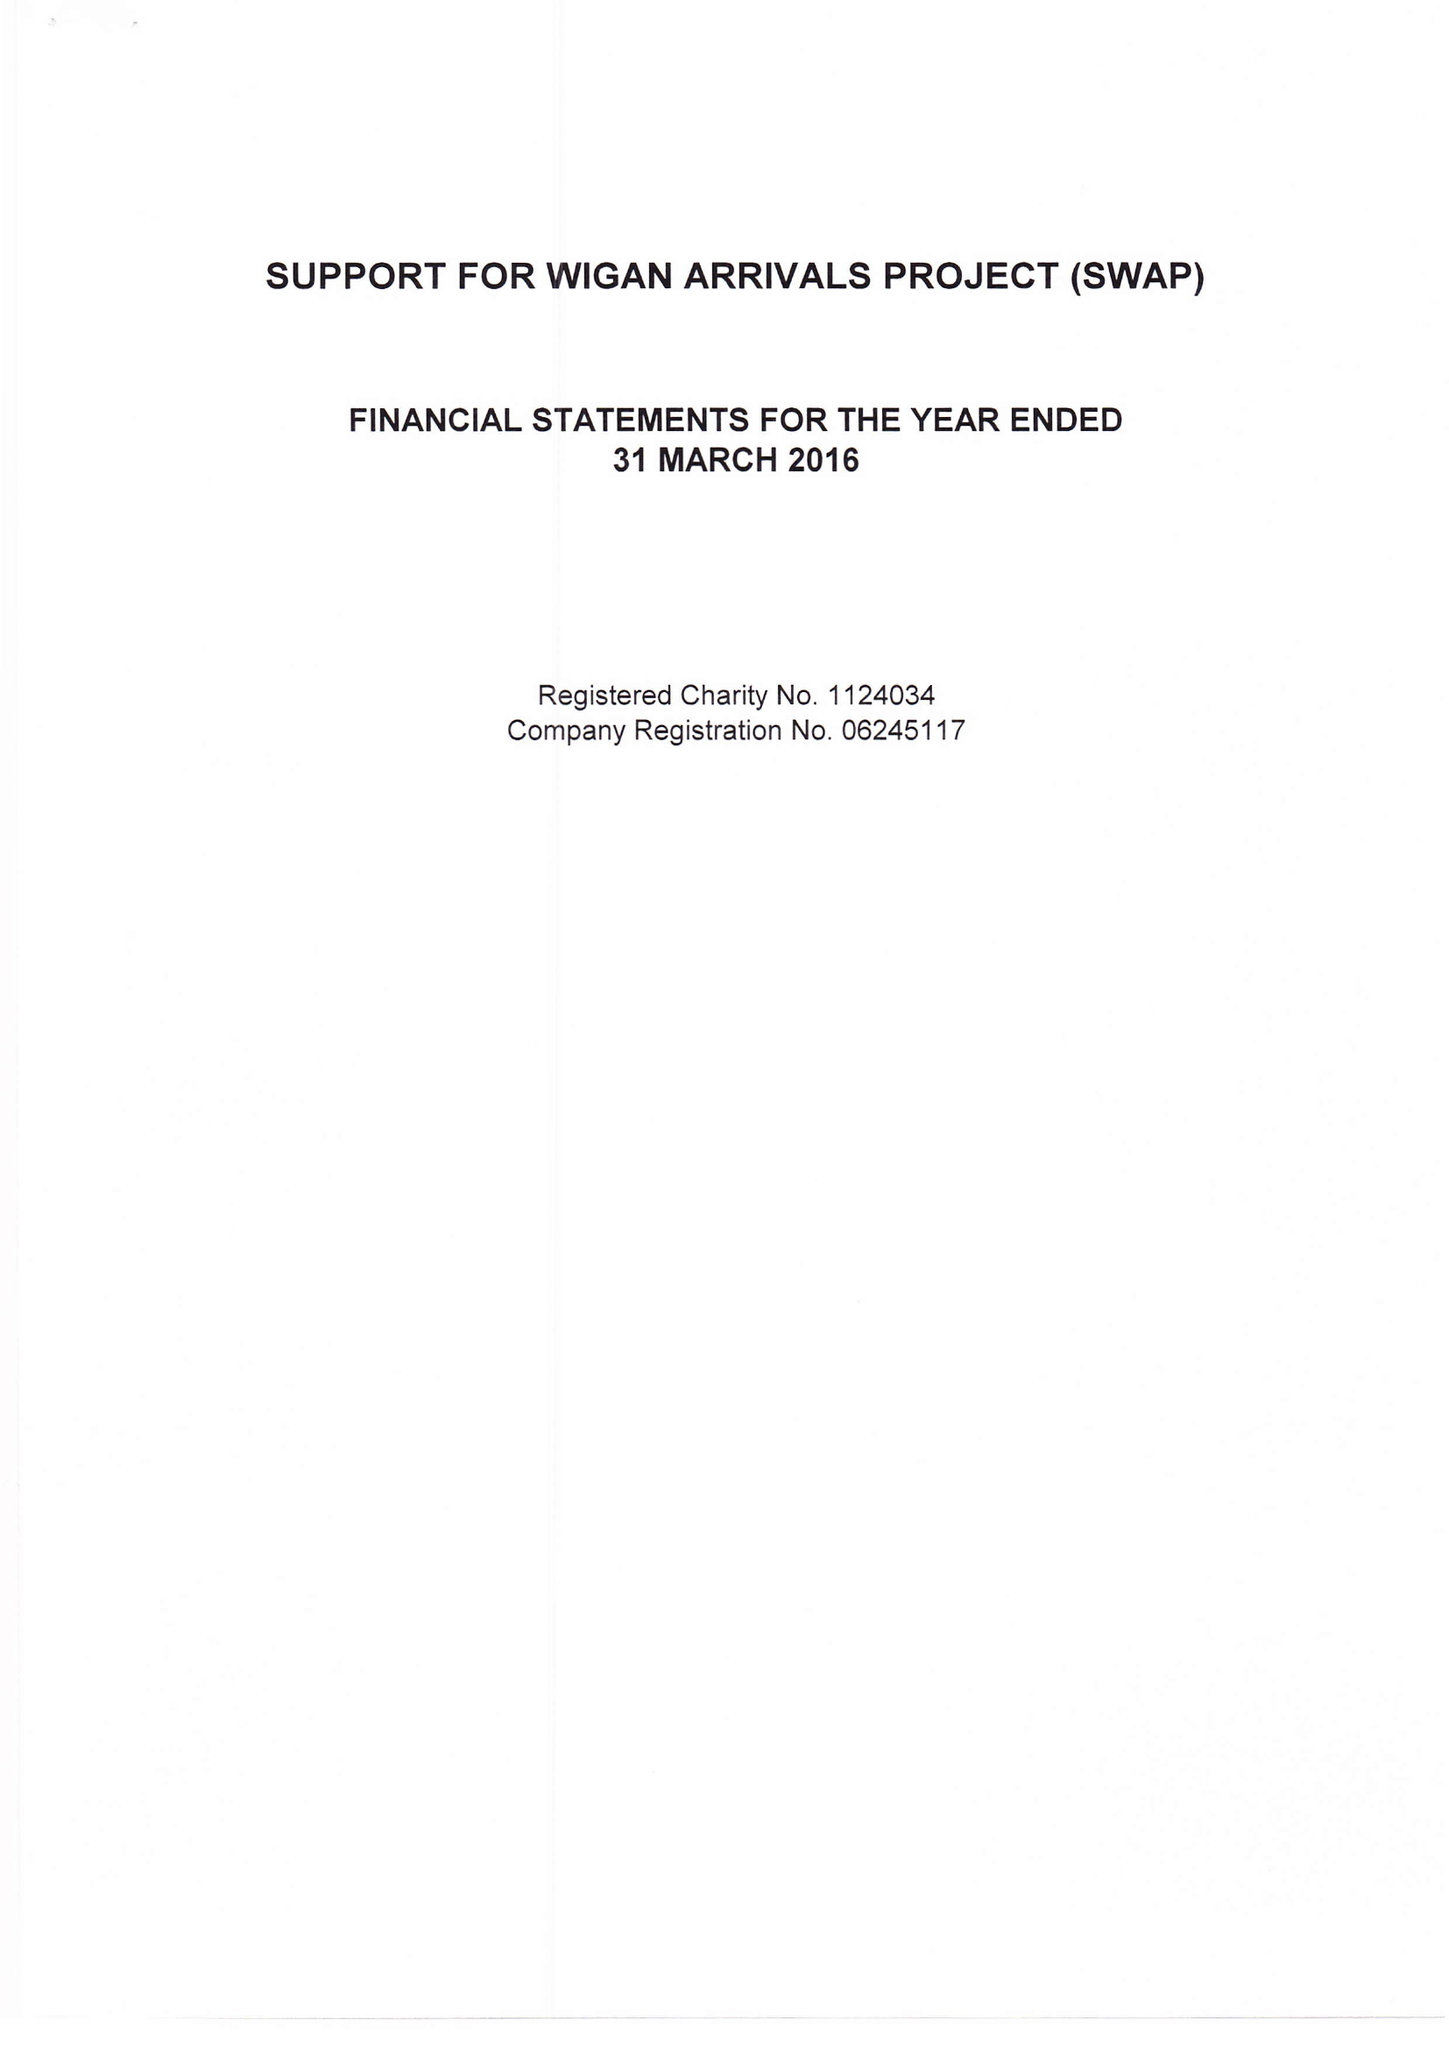What is the value for the address__street_line?
Answer the question using a single word or phrase. PENSON STREET 